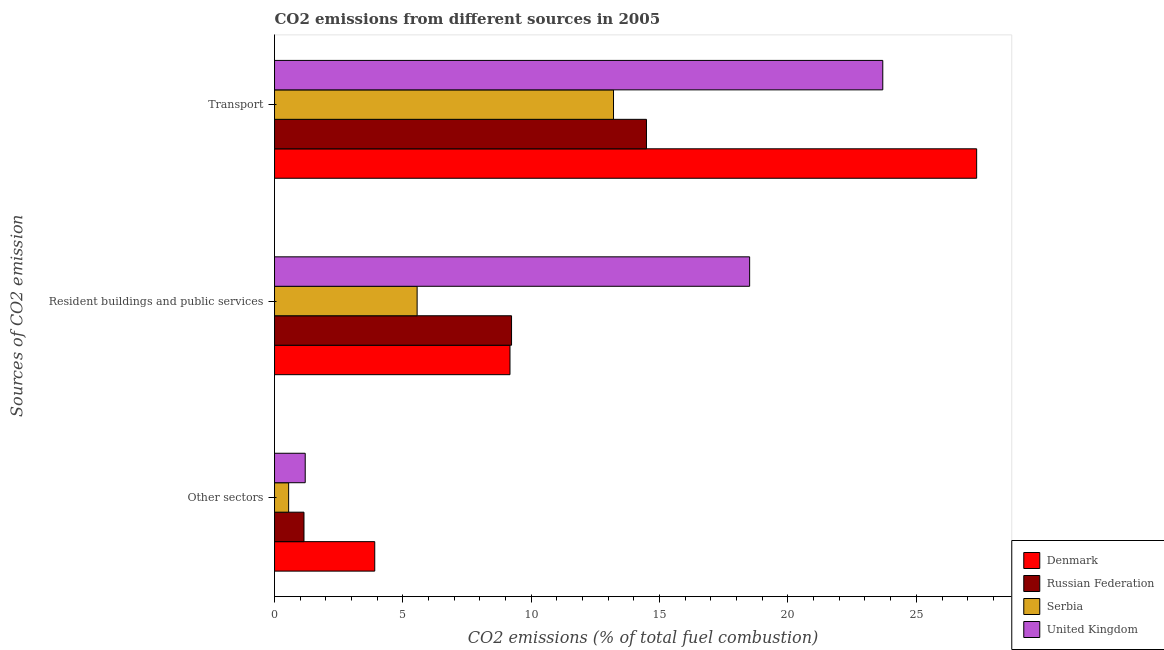How many different coloured bars are there?
Provide a short and direct response. 4. Are the number of bars per tick equal to the number of legend labels?
Your answer should be very brief. Yes. Are the number of bars on each tick of the Y-axis equal?
Keep it short and to the point. Yes. What is the label of the 2nd group of bars from the top?
Keep it short and to the point. Resident buildings and public services. What is the percentage of co2 emissions from transport in United Kingdom?
Offer a very short reply. 23.69. Across all countries, what is the maximum percentage of co2 emissions from other sectors?
Keep it short and to the point. 3.9. Across all countries, what is the minimum percentage of co2 emissions from other sectors?
Ensure brevity in your answer.  0.55. In which country was the percentage of co2 emissions from resident buildings and public services maximum?
Offer a terse response. United Kingdom. In which country was the percentage of co2 emissions from transport minimum?
Make the answer very short. Serbia. What is the total percentage of co2 emissions from resident buildings and public services in the graph?
Provide a succinct answer. 42.47. What is the difference between the percentage of co2 emissions from other sectors in Serbia and that in Russian Federation?
Offer a very short reply. -0.6. What is the difference between the percentage of co2 emissions from resident buildings and public services in Russian Federation and the percentage of co2 emissions from other sectors in Denmark?
Provide a succinct answer. 5.33. What is the average percentage of co2 emissions from resident buildings and public services per country?
Provide a succinct answer. 10.62. What is the difference between the percentage of co2 emissions from transport and percentage of co2 emissions from resident buildings and public services in United Kingdom?
Provide a succinct answer. 5.19. In how many countries, is the percentage of co2 emissions from resident buildings and public services greater than 20 %?
Provide a succinct answer. 0. What is the ratio of the percentage of co2 emissions from transport in United Kingdom to that in Denmark?
Provide a succinct answer. 0.87. Is the percentage of co2 emissions from transport in Serbia less than that in Denmark?
Keep it short and to the point. Yes. What is the difference between the highest and the second highest percentage of co2 emissions from transport?
Offer a very short reply. 3.66. What is the difference between the highest and the lowest percentage of co2 emissions from resident buildings and public services?
Your answer should be compact. 12.95. In how many countries, is the percentage of co2 emissions from resident buildings and public services greater than the average percentage of co2 emissions from resident buildings and public services taken over all countries?
Give a very brief answer. 1. What does the 3rd bar from the bottom in Transport represents?
Provide a succinct answer. Serbia. Is it the case that in every country, the sum of the percentage of co2 emissions from other sectors and percentage of co2 emissions from resident buildings and public services is greater than the percentage of co2 emissions from transport?
Offer a very short reply. No. How many bars are there?
Make the answer very short. 12. What is the difference between two consecutive major ticks on the X-axis?
Offer a terse response. 5. Does the graph contain grids?
Keep it short and to the point. No. Where does the legend appear in the graph?
Keep it short and to the point. Bottom right. How many legend labels are there?
Keep it short and to the point. 4. What is the title of the graph?
Ensure brevity in your answer.  CO2 emissions from different sources in 2005. Does "High income: nonOECD" appear as one of the legend labels in the graph?
Give a very brief answer. No. What is the label or title of the X-axis?
Your answer should be compact. CO2 emissions (% of total fuel combustion). What is the label or title of the Y-axis?
Give a very brief answer. Sources of CO2 emission. What is the CO2 emissions (% of total fuel combustion) of Denmark in Other sectors?
Keep it short and to the point. 3.9. What is the CO2 emissions (% of total fuel combustion) of Russian Federation in Other sectors?
Your answer should be compact. 1.15. What is the CO2 emissions (% of total fuel combustion) of Serbia in Other sectors?
Ensure brevity in your answer.  0.55. What is the CO2 emissions (% of total fuel combustion) of United Kingdom in Other sectors?
Ensure brevity in your answer.  1.2. What is the CO2 emissions (% of total fuel combustion) in Denmark in Resident buildings and public services?
Provide a short and direct response. 9.17. What is the CO2 emissions (% of total fuel combustion) of Russian Federation in Resident buildings and public services?
Provide a short and direct response. 9.23. What is the CO2 emissions (% of total fuel combustion) in Serbia in Resident buildings and public services?
Offer a terse response. 5.55. What is the CO2 emissions (% of total fuel combustion) in United Kingdom in Resident buildings and public services?
Provide a succinct answer. 18.51. What is the CO2 emissions (% of total fuel combustion) in Denmark in Transport?
Provide a succinct answer. 27.35. What is the CO2 emissions (% of total fuel combustion) of Russian Federation in Transport?
Offer a terse response. 14.49. What is the CO2 emissions (% of total fuel combustion) in Serbia in Transport?
Your response must be concise. 13.2. What is the CO2 emissions (% of total fuel combustion) in United Kingdom in Transport?
Your answer should be compact. 23.69. Across all Sources of CO2 emission, what is the maximum CO2 emissions (% of total fuel combustion) in Denmark?
Offer a terse response. 27.35. Across all Sources of CO2 emission, what is the maximum CO2 emissions (% of total fuel combustion) in Russian Federation?
Provide a succinct answer. 14.49. Across all Sources of CO2 emission, what is the maximum CO2 emissions (% of total fuel combustion) in Serbia?
Your answer should be compact. 13.2. Across all Sources of CO2 emission, what is the maximum CO2 emissions (% of total fuel combustion) of United Kingdom?
Provide a succinct answer. 23.69. Across all Sources of CO2 emission, what is the minimum CO2 emissions (% of total fuel combustion) in Denmark?
Offer a very short reply. 3.9. Across all Sources of CO2 emission, what is the minimum CO2 emissions (% of total fuel combustion) of Russian Federation?
Offer a very short reply. 1.15. Across all Sources of CO2 emission, what is the minimum CO2 emissions (% of total fuel combustion) of Serbia?
Your answer should be very brief. 0.55. Across all Sources of CO2 emission, what is the minimum CO2 emissions (% of total fuel combustion) of United Kingdom?
Provide a succinct answer. 1.2. What is the total CO2 emissions (% of total fuel combustion) of Denmark in the graph?
Your response must be concise. 40.43. What is the total CO2 emissions (% of total fuel combustion) of Russian Federation in the graph?
Offer a very short reply. 24.87. What is the total CO2 emissions (% of total fuel combustion) of Serbia in the graph?
Your answer should be very brief. 19.31. What is the total CO2 emissions (% of total fuel combustion) of United Kingdom in the graph?
Keep it short and to the point. 43.4. What is the difference between the CO2 emissions (% of total fuel combustion) of Denmark in Other sectors and that in Resident buildings and public services?
Give a very brief answer. -5.27. What is the difference between the CO2 emissions (% of total fuel combustion) of Russian Federation in Other sectors and that in Resident buildings and public services?
Give a very brief answer. -8.08. What is the difference between the CO2 emissions (% of total fuel combustion) of Serbia in Other sectors and that in Resident buildings and public services?
Provide a short and direct response. -5.01. What is the difference between the CO2 emissions (% of total fuel combustion) in United Kingdom in Other sectors and that in Resident buildings and public services?
Keep it short and to the point. -17.31. What is the difference between the CO2 emissions (% of total fuel combustion) in Denmark in Other sectors and that in Transport?
Your answer should be compact. -23.45. What is the difference between the CO2 emissions (% of total fuel combustion) in Russian Federation in Other sectors and that in Transport?
Provide a short and direct response. -13.34. What is the difference between the CO2 emissions (% of total fuel combustion) of Serbia in Other sectors and that in Transport?
Offer a terse response. -12.66. What is the difference between the CO2 emissions (% of total fuel combustion) in United Kingdom in Other sectors and that in Transport?
Offer a terse response. -22.5. What is the difference between the CO2 emissions (% of total fuel combustion) in Denmark in Resident buildings and public services and that in Transport?
Give a very brief answer. -18.18. What is the difference between the CO2 emissions (% of total fuel combustion) in Russian Federation in Resident buildings and public services and that in Transport?
Make the answer very short. -5.26. What is the difference between the CO2 emissions (% of total fuel combustion) of Serbia in Resident buildings and public services and that in Transport?
Provide a short and direct response. -7.65. What is the difference between the CO2 emissions (% of total fuel combustion) of United Kingdom in Resident buildings and public services and that in Transport?
Your response must be concise. -5.19. What is the difference between the CO2 emissions (% of total fuel combustion) in Denmark in Other sectors and the CO2 emissions (% of total fuel combustion) in Russian Federation in Resident buildings and public services?
Your response must be concise. -5.33. What is the difference between the CO2 emissions (% of total fuel combustion) in Denmark in Other sectors and the CO2 emissions (% of total fuel combustion) in Serbia in Resident buildings and public services?
Keep it short and to the point. -1.65. What is the difference between the CO2 emissions (% of total fuel combustion) of Denmark in Other sectors and the CO2 emissions (% of total fuel combustion) of United Kingdom in Resident buildings and public services?
Make the answer very short. -14.6. What is the difference between the CO2 emissions (% of total fuel combustion) of Russian Federation in Other sectors and the CO2 emissions (% of total fuel combustion) of Serbia in Resident buildings and public services?
Offer a terse response. -4.41. What is the difference between the CO2 emissions (% of total fuel combustion) in Russian Federation in Other sectors and the CO2 emissions (% of total fuel combustion) in United Kingdom in Resident buildings and public services?
Give a very brief answer. -17.36. What is the difference between the CO2 emissions (% of total fuel combustion) in Serbia in Other sectors and the CO2 emissions (% of total fuel combustion) in United Kingdom in Resident buildings and public services?
Provide a short and direct response. -17.96. What is the difference between the CO2 emissions (% of total fuel combustion) in Denmark in Other sectors and the CO2 emissions (% of total fuel combustion) in Russian Federation in Transport?
Keep it short and to the point. -10.58. What is the difference between the CO2 emissions (% of total fuel combustion) in Denmark in Other sectors and the CO2 emissions (% of total fuel combustion) in Serbia in Transport?
Your response must be concise. -9.3. What is the difference between the CO2 emissions (% of total fuel combustion) of Denmark in Other sectors and the CO2 emissions (% of total fuel combustion) of United Kingdom in Transport?
Offer a terse response. -19.79. What is the difference between the CO2 emissions (% of total fuel combustion) in Russian Federation in Other sectors and the CO2 emissions (% of total fuel combustion) in Serbia in Transport?
Offer a very short reply. -12.06. What is the difference between the CO2 emissions (% of total fuel combustion) in Russian Federation in Other sectors and the CO2 emissions (% of total fuel combustion) in United Kingdom in Transport?
Provide a short and direct response. -22.55. What is the difference between the CO2 emissions (% of total fuel combustion) in Serbia in Other sectors and the CO2 emissions (% of total fuel combustion) in United Kingdom in Transport?
Your answer should be very brief. -23.14. What is the difference between the CO2 emissions (% of total fuel combustion) in Denmark in Resident buildings and public services and the CO2 emissions (% of total fuel combustion) in Russian Federation in Transport?
Your answer should be compact. -5.32. What is the difference between the CO2 emissions (% of total fuel combustion) of Denmark in Resident buildings and public services and the CO2 emissions (% of total fuel combustion) of Serbia in Transport?
Provide a succinct answer. -4.03. What is the difference between the CO2 emissions (% of total fuel combustion) of Denmark in Resident buildings and public services and the CO2 emissions (% of total fuel combustion) of United Kingdom in Transport?
Your response must be concise. -14.52. What is the difference between the CO2 emissions (% of total fuel combustion) of Russian Federation in Resident buildings and public services and the CO2 emissions (% of total fuel combustion) of Serbia in Transport?
Make the answer very short. -3.97. What is the difference between the CO2 emissions (% of total fuel combustion) in Russian Federation in Resident buildings and public services and the CO2 emissions (% of total fuel combustion) in United Kingdom in Transport?
Keep it short and to the point. -14.46. What is the difference between the CO2 emissions (% of total fuel combustion) of Serbia in Resident buildings and public services and the CO2 emissions (% of total fuel combustion) of United Kingdom in Transport?
Provide a succinct answer. -18.14. What is the average CO2 emissions (% of total fuel combustion) of Denmark per Sources of CO2 emission?
Provide a short and direct response. 13.48. What is the average CO2 emissions (% of total fuel combustion) of Russian Federation per Sources of CO2 emission?
Keep it short and to the point. 8.29. What is the average CO2 emissions (% of total fuel combustion) in Serbia per Sources of CO2 emission?
Provide a short and direct response. 6.44. What is the average CO2 emissions (% of total fuel combustion) in United Kingdom per Sources of CO2 emission?
Your answer should be very brief. 14.46. What is the difference between the CO2 emissions (% of total fuel combustion) of Denmark and CO2 emissions (% of total fuel combustion) of Russian Federation in Other sectors?
Your answer should be compact. 2.76. What is the difference between the CO2 emissions (% of total fuel combustion) in Denmark and CO2 emissions (% of total fuel combustion) in Serbia in Other sectors?
Your answer should be very brief. 3.35. What is the difference between the CO2 emissions (% of total fuel combustion) in Denmark and CO2 emissions (% of total fuel combustion) in United Kingdom in Other sectors?
Offer a terse response. 2.71. What is the difference between the CO2 emissions (% of total fuel combustion) in Russian Federation and CO2 emissions (% of total fuel combustion) in Serbia in Other sectors?
Keep it short and to the point. 0.6. What is the difference between the CO2 emissions (% of total fuel combustion) in Russian Federation and CO2 emissions (% of total fuel combustion) in United Kingdom in Other sectors?
Give a very brief answer. -0.05. What is the difference between the CO2 emissions (% of total fuel combustion) in Serbia and CO2 emissions (% of total fuel combustion) in United Kingdom in Other sectors?
Offer a very short reply. -0.65. What is the difference between the CO2 emissions (% of total fuel combustion) in Denmark and CO2 emissions (% of total fuel combustion) in Russian Federation in Resident buildings and public services?
Offer a very short reply. -0.06. What is the difference between the CO2 emissions (% of total fuel combustion) of Denmark and CO2 emissions (% of total fuel combustion) of Serbia in Resident buildings and public services?
Offer a terse response. 3.62. What is the difference between the CO2 emissions (% of total fuel combustion) of Denmark and CO2 emissions (% of total fuel combustion) of United Kingdom in Resident buildings and public services?
Your answer should be compact. -9.34. What is the difference between the CO2 emissions (% of total fuel combustion) of Russian Federation and CO2 emissions (% of total fuel combustion) of Serbia in Resident buildings and public services?
Your answer should be compact. 3.68. What is the difference between the CO2 emissions (% of total fuel combustion) of Russian Federation and CO2 emissions (% of total fuel combustion) of United Kingdom in Resident buildings and public services?
Offer a terse response. -9.27. What is the difference between the CO2 emissions (% of total fuel combustion) in Serbia and CO2 emissions (% of total fuel combustion) in United Kingdom in Resident buildings and public services?
Ensure brevity in your answer.  -12.95. What is the difference between the CO2 emissions (% of total fuel combustion) of Denmark and CO2 emissions (% of total fuel combustion) of Russian Federation in Transport?
Offer a very short reply. 12.86. What is the difference between the CO2 emissions (% of total fuel combustion) in Denmark and CO2 emissions (% of total fuel combustion) in Serbia in Transport?
Offer a very short reply. 14.15. What is the difference between the CO2 emissions (% of total fuel combustion) in Denmark and CO2 emissions (% of total fuel combustion) in United Kingdom in Transport?
Provide a succinct answer. 3.66. What is the difference between the CO2 emissions (% of total fuel combustion) in Russian Federation and CO2 emissions (% of total fuel combustion) in Serbia in Transport?
Provide a short and direct response. 1.28. What is the difference between the CO2 emissions (% of total fuel combustion) of Russian Federation and CO2 emissions (% of total fuel combustion) of United Kingdom in Transport?
Your answer should be very brief. -9.2. What is the difference between the CO2 emissions (% of total fuel combustion) in Serbia and CO2 emissions (% of total fuel combustion) in United Kingdom in Transport?
Your answer should be compact. -10.49. What is the ratio of the CO2 emissions (% of total fuel combustion) in Denmark in Other sectors to that in Resident buildings and public services?
Provide a succinct answer. 0.43. What is the ratio of the CO2 emissions (% of total fuel combustion) of Russian Federation in Other sectors to that in Resident buildings and public services?
Keep it short and to the point. 0.12. What is the ratio of the CO2 emissions (% of total fuel combustion) in Serbia in Other sectors to that in Resident buildings and public services?
Keep it short and to the point. 0.1. What is the ratio of the CO2 emissions (% of total fuel combustion) of United Kingdom in Other sectors to that in Resident buildings and public services?
Keep it short and to the point. 0.06. What is the ratio of the CO2 emissions (% of total fuel combustion) of Denmark in Other sectors to that in Transport?
Your answer should be compact. 0.14. What is the ratio of the CO2 emissions (% of total fuel combustion) in Russian Federation in Other sectors to that in Transport?
Give a very brief answer. 0.08. What is the ratio of the CO2 emissions (% of total fuel combustion) of Serbia in Other sectors to that in Transport?
Your answer should be compact. 0.04. What is the ratio of the CO2 emissions (% of total fuel combustion) in United Kingdom in Other sectors to that in Transport?
Keep it short and to the point. 0.05. What is the ratio of the CO2 emissions (% of total fuel combustion) in Denmark in Resident buildings and public services to that in Transport?
Your answer should be very brief. 0.34. What is the ratio of the CO2 emissions (% of total fuel combustion) in Russian Federation in Resident buildings and public services to that in Transport?
Keep it short and to the point. 0.64. What is the ratio of the CO2 emissions (% of total fuel combustion) of Serbia in Resident buildings and public services to that in Transport?
Keep it short and to the point. 0.42. What is the ratio of the CO2 emissions (% of total fuel combustion) in United Kingdom in Resident buildings and public services to that in Transport?
Your response must be concise. 0.78. What is the difference between the highest and the second highest CO2 emissions (% of total fuel combustion) of Denmark?
Ensure brevity in your answer.  18.18. What is the difference between the highest and the second highest CO2 emissions (% of total fuel combustion) of Russian Federation?
Keep it short and to the point. 5.26. What is the difference between the highest and the second highest CO2 emissions (% of total fuel combustion) in Serbia?
Your response must be concise. 7.65. What is the difference between the highest and the second highest CO2 emissions (% of total fuel combustion) of United Kingdom?
Provide a short and direct response. 5.19. What is the difference between the highest and the lowest CO2 emissions (% of total fuel combustion) of Denmark?
Offer a very short reply. 23.45. What is the difference between the highest and the lowest CO2 emissions (% of total fuel combustion) in Russian Federation?
Make the answer very short. 13.34. What is the difference between the highest and the lowest CO2 emissions (% of total fuel combustion) in Serbia?
Offer a terse response. 12.66. What is the difference between the highest and the lowest CO2 emissions (% of total fuel combustion) of United Kingdom?
Keep it short and to the point. 22.5. 